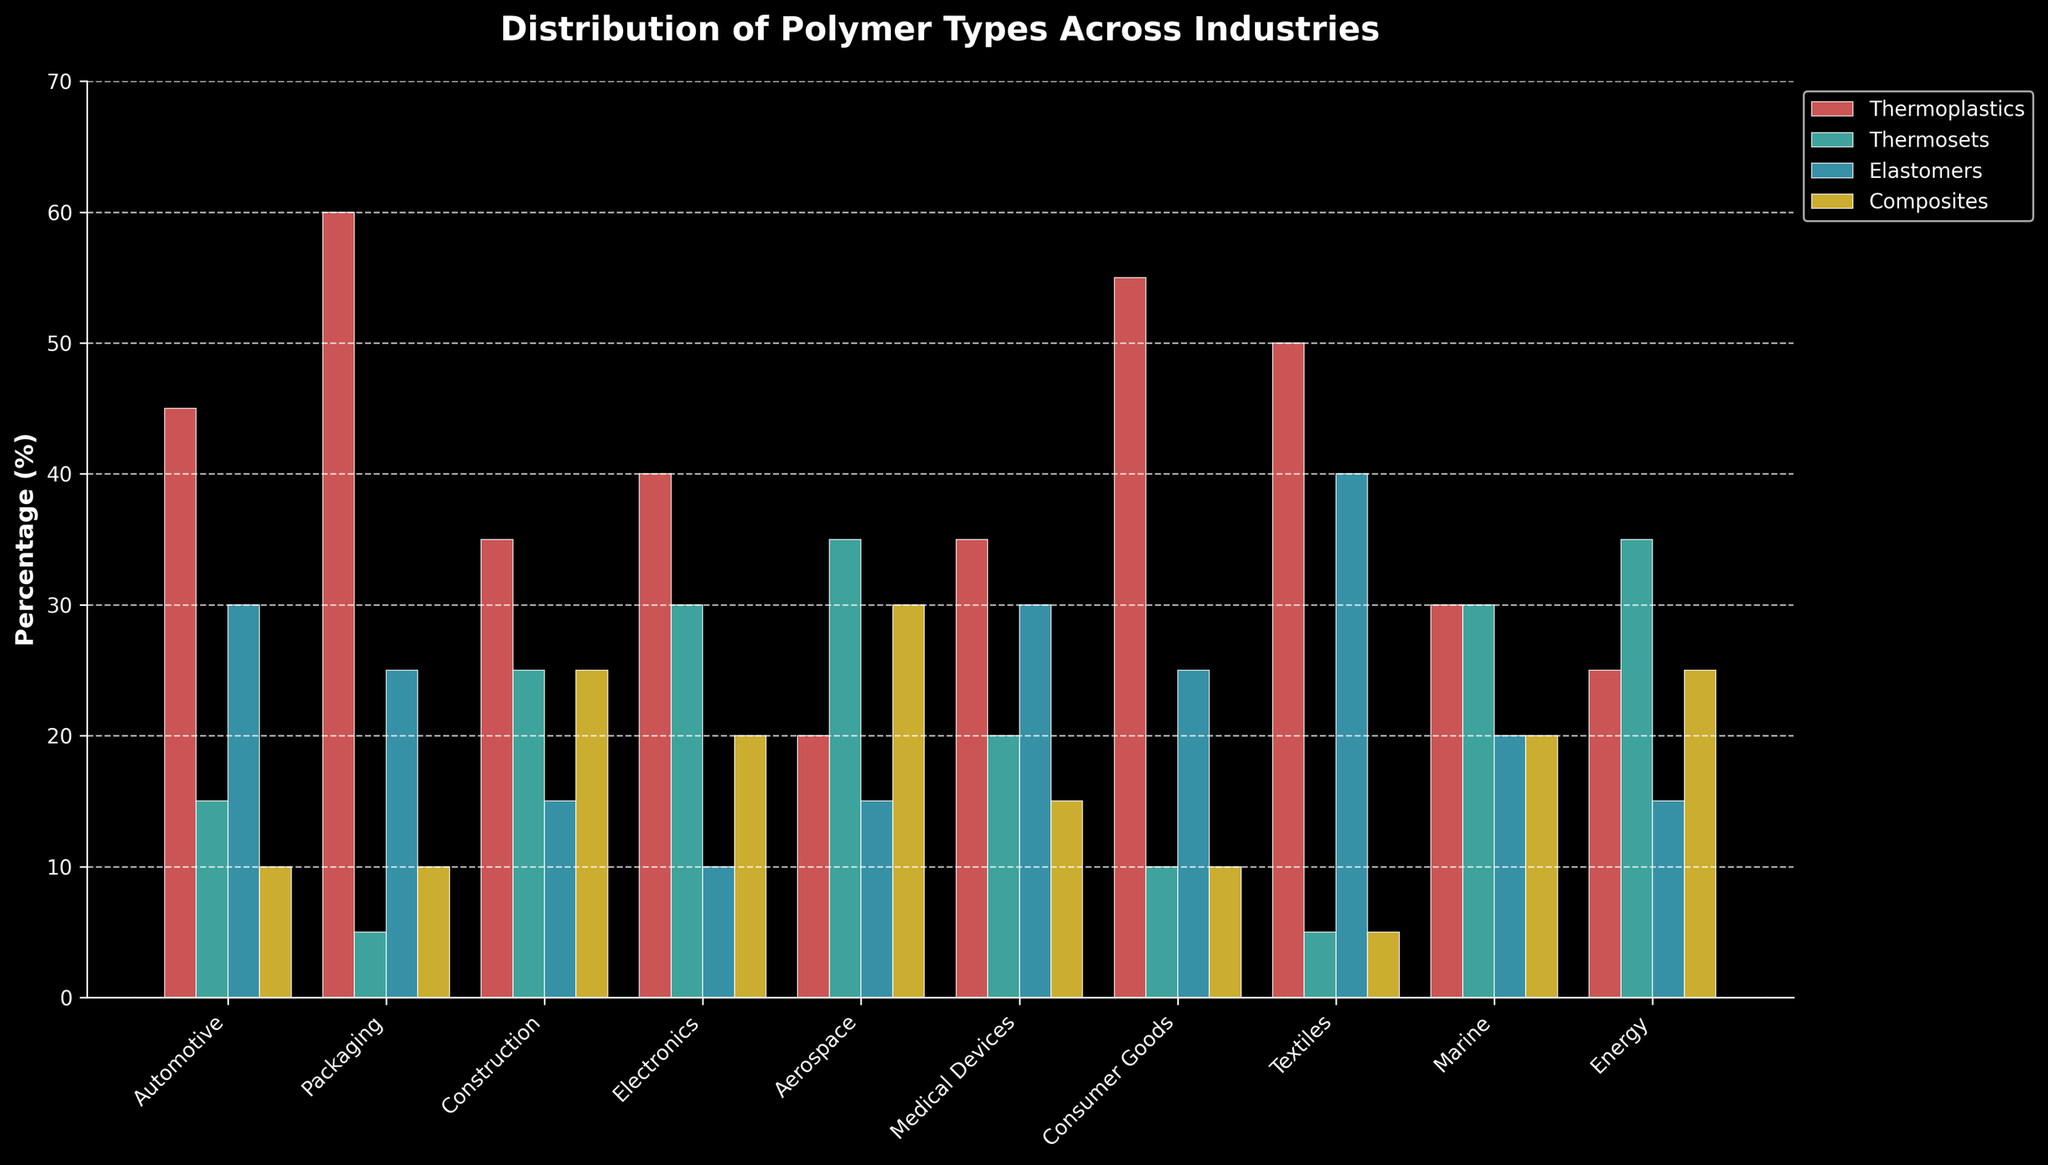Which industry uses the highest percentage of thermoplastics? By visually comparing the heights of the thermoplastics bars (red color) across industries, the tallest bar represents the highest percentage, which is in the Packaging industry.
Answer: Packaging Which industry has the lowest utilization of elastomers? By comparing the heights of the elastomers bars (green color) across industries, the shortest bar represents the lowest utilization, found in the Electronics industry.
Answer: Electronics How many industries use over 30% of composites? Count the industries where the height of the yellow composites bar exceeds the 30% mark on the y-axis. Only Aerospace and Construction industries meet this criterion.
Answer: 2 Compare the usage of thermosets in the Electronics and Energy industries. Which one has a higher percentage and by how much? By visually comparing the heights of the thermosets bars (cyan color) in Electronics and Energy, Electronics has a taller bar. The difference is 30% - 35% = -5%, so Energy has a higher percentage by 5%.
Answer: Energy, 5% What is the total percentage of polymers (all types) used in the Automotive industry? Sum the heights of all bars (thermoplastics, thermosets, elastomers, composites) for the Automotive industry: 45% + 15% + 30% + 10% = 100%.
Answer: 100% Which industry uses an equal percentage of thermosets and composites? Look for industries where the heights of the cyan and yellow bars are the same. For the Marine and Energy industries, the bars are both at 30% and 25%, respectively.
Answer: Marine, Energy Is the percentage of elastomers higher in Automotive or Medical Devices? By how much? Compare the heights of the green elastomer bars in both industries. Automotive has 30%, while Medical Devices also have 30%. The difference is 0%.
Answer: Equal, 0% Which industry shows a greater diversity in polymer types used, considering the spread of percentages among the four types? The spread can be observed where the heights of bars vary the most within an industry. The Construction industry has significantly diverse usage: thermoplastics (35%), thermosets (25%), elastomers (15%), and composites (25%).
Answer: Construction What is the combined percentage of thermosets and composites used in the Aerospace industry? Add the percentages of thermosets and composites for the Aerospace industry: 35% + 30% = 65%.
Answer: 65% Which industry has the second-highest usage of thermoplastics? By visually comparing the heights of the red thermoplastics bars, the tallest is Packaging, and the second tallest is Consumer Goods at 55%.
Answer: Consumer Goods 